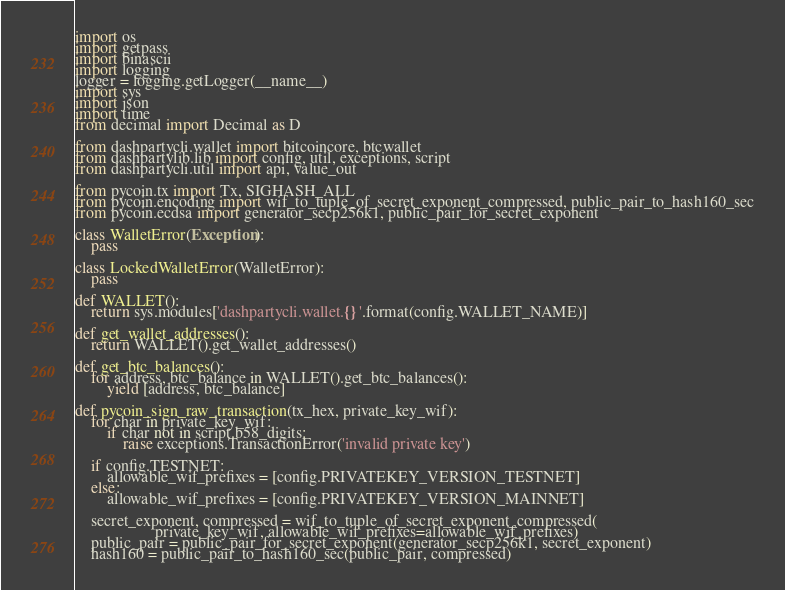<code> <loc_0><loc_0><loc_500><loc_500><_Python_>import os
import getpass
import binascii
import logging
logger = logging.getLogger(__name__)
import sys
import json
import time
from decimal import Decimal as D

from dashpartycli.wallet import bitcoincore, btcwallet
from dashpartylib.lib import config, util, exceptions, script
from dashpartycli.util import api, value_out

from pycoin.tx import Tx, SIGHASH_ALL
from pycoin.encoding import wif_to_tuple_of_secret_exponent_compressed, public_pair_to_hash160_sec
from pycoin.ecdsa import generator_secp256k1, public_pair_for_secret_exponent

class WalletError(Exception):
    pass

class LockedWalletError(WalletError):
    pass

def WALLET():
    return sys.modules['dashpartycli.wallet.{}'.format(config.WALLET_NAME)]

def get_wallet_addresses():
    return WALLET().get_wallet_addresses()

def get_btc_balances():
    for address, btc_balance in WALLET().get_btc_balances():
    	yield [address, btc_balance]

def pycoin_sign_raw_transaction(tx_hex, private_key_wif):
    for char in private_key_wif:
        if char not in script.b58_digits:
            raise exceptions.TransactionError('invalid private key')

    if config.TESTNET:
        allowable_wif_prefixes = [config.PRIVATEKEY_VERSION_TESTNET]
    else:
        allowable_wif_prefixes = [config.PRIVATEKEY_VERSION_MAINNET]

    secret_exponent, compressed = wif_to_tuple_of_secret_exponent_compressed(
                    private_key_wif, allowable_wif_prefixes=allowable_wif_prefixes)
    public_pair = public_pair_for_secret_exponent(generator_secp256k1, secret_exponent)
    hash160 = public_pair_to_hash160_sec(public_pair, compressed)</code> 